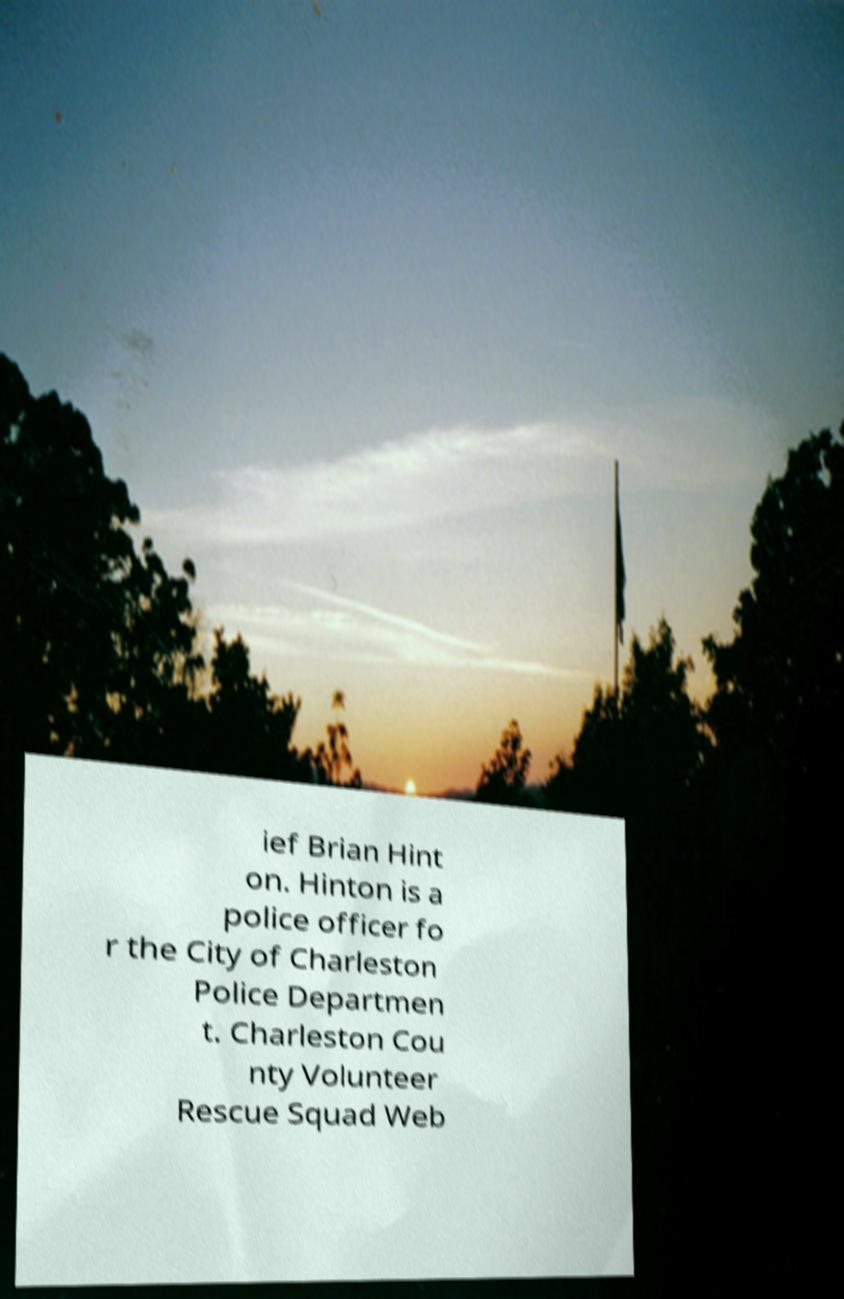I need the written content from this picture converted into text. Can you do that? ief Brian Hint on. Hinton is a police officer fo r the City of Charleston Police Departmen t. Charleston Cou nty Volunteer Rescue Squad Web 